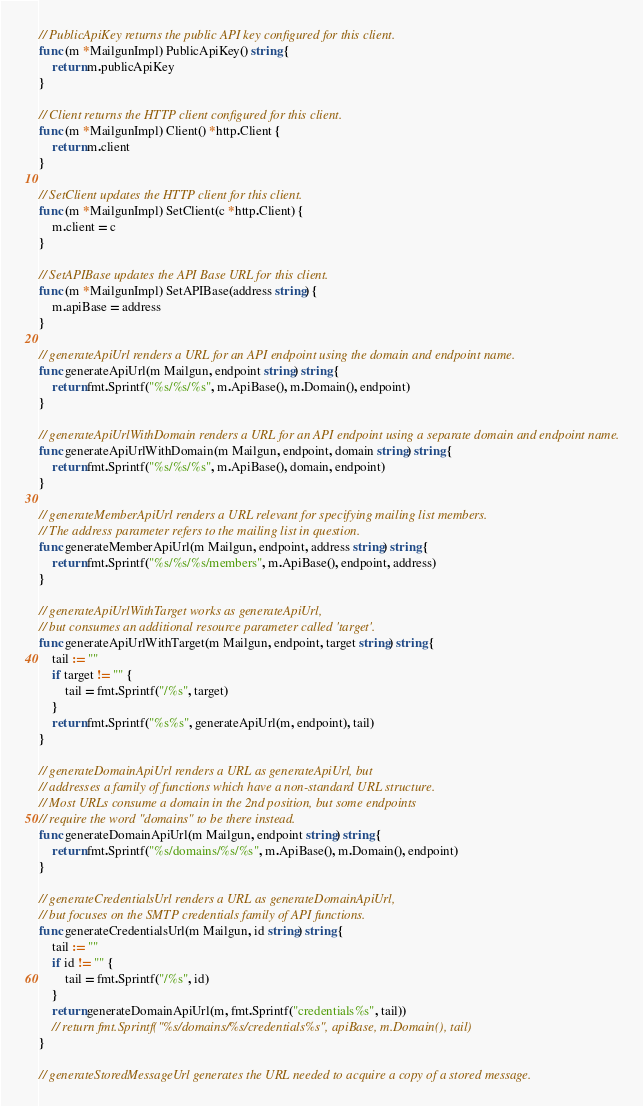Convert code to text. <code><loc_0><loc_0><loc_500><loc_500><_Go_>// PublicApiKey returns the public API key configured for this client.
func (m *MailgunImpl) PublicApiKey() string {
	return m.publicApiKey
}

// Client returns the HTTP client configured for this client.
func (m *MailgunImpl) Client() *http.Client {
	return m.client
}

// SetClient updates the HTTP client for this client.
func (m *MailgunImpl) SetClient(c *http.Client) {
	m.client = c
}

// SetAPIBase updates the API Base URL for this client.
func (m *MailgunImpl) SetAPIBase(address string) {
	m.apiBase = address
}

// generateApiUrl renders a URL for an API endpoint using the domain and endpoint name.
func generateApiUrl(m Mailgun, endpoint string) string {
	return fmt.Sprintf("%s/%s/%s", m.ApiBase(), m.Domain(), endpoint)
}

// generateApiUrlWithDomain renders a URL for an API endpoint using a separate domain and endpoint name.
func generateApiUrlWithDomain(m Mailgun, endpoint, domain string) string {
	return fmt.Sprintf("%s/%s/%s", m.ApiBase(), domain, endpoint)
}

// generateMemberApiUrl renders a URL relevant for specifying mailing list members.
// The address parameter refers to the mailing list in question.
func generateMemberApiUrl(m Mailgun, endpoint, address string) string {
	return fmt.Sprintf("%s/%s/%s/members", m.ApiBase(), endpoint, address)
}

// generateApiUrlWithTarget works as generateApiUrl,
// but consumes an additional resource parameter called 'target'.
func generateApiUrlWithTarget(m Mailgun, endpoint, target string) string {
	tail := ""
	if target != "" {
		tail = fmt.Sprintf("/%s", target)
	}
	return fmt.Sprintf("%s%s", generateApiUrl(m, endpoint), tail)
}

// generateDomainApiUrl renders a URL as generateApiUrl, but
// addresses a family of functions which have a non-standard URL structure.
// Most URLs consume a domain in the 2nd position, but some endpoints
// require the word "domains" to be there instead.
func generateDomainApiUrl(m Mailgun, endpoint string) string {
	return fmt.Sprintf("%s/domains/%s/%s", m.ApiBase(), m.Domain(), endpoint)
}

// generateCredentialsUrl renders a URL as generateDomainApiUrl,
// but focuses on the SMTP credentials family of API functions.
func generateCredentialsUrl(m Mailgun, id string) string {
	tail := ""
	if id != "" {
		tail = fmt.Sprintf("/%s", id)
	}
	return generateDomainApiUrl(m, fmt.Sprintf("credentials%s", tail))
	// return fmt.Sprintf("%s/domains/%s/credentials%s", apiBase, m.Domain(), tail)
}

// generateStoredMessageUrl generates the URL needed to acquire a copy of a stored message.</code> 